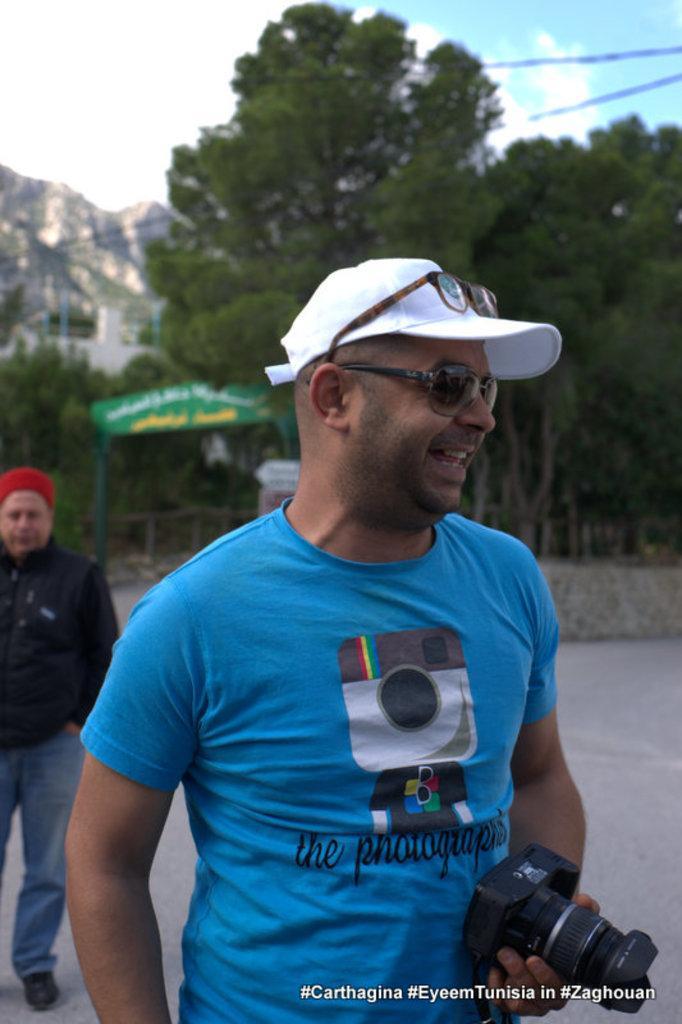How would you summarize this image in a sentence or two? In the middle of the image a man is standing and holding a camera and smiling. Behind him there are some trees and there is a hill. Bottom left side of the image there is a man standing. Top right side of the image there is a sky. Top left of the image there are some clouds. 